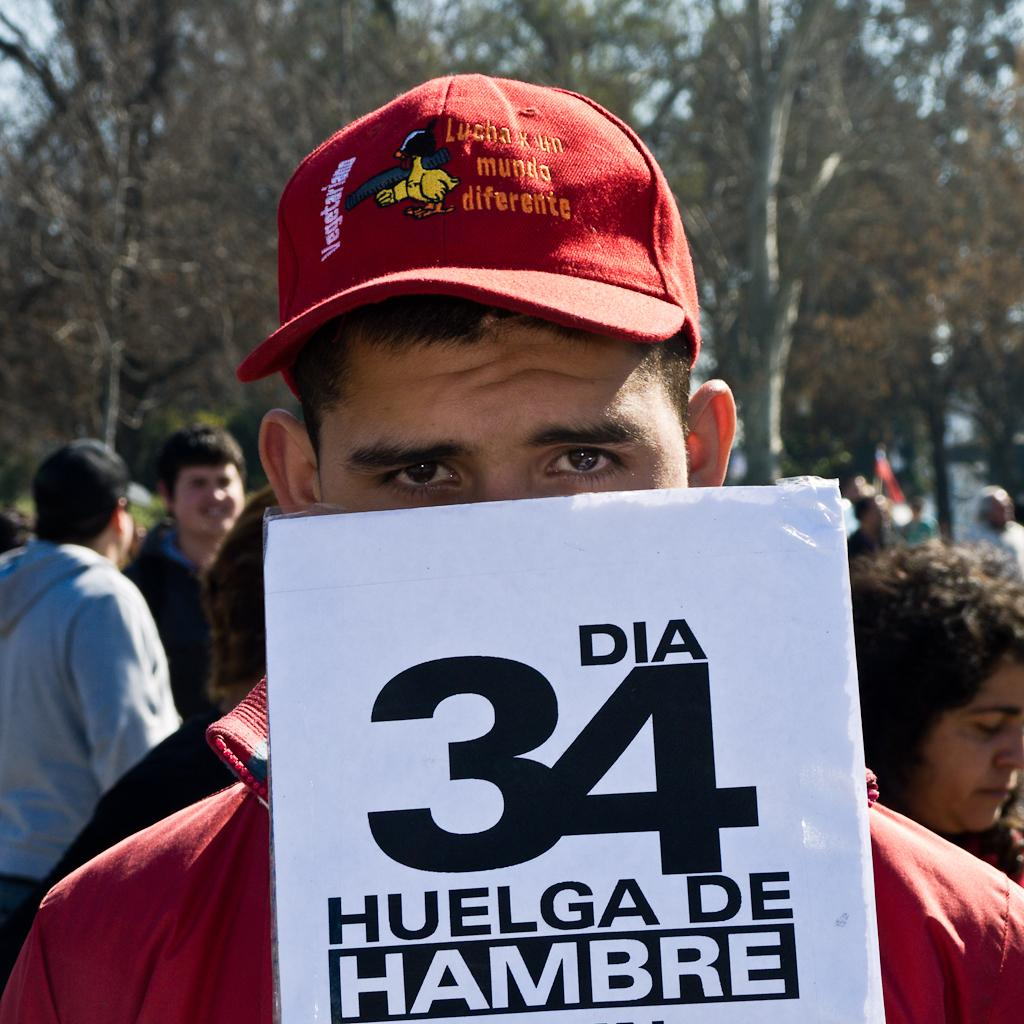How many people are in the image? There are multiple persons in the image. Can you describe the man in the front of the image? The man in the front of the image is holding some paper and wearing a cap. What is visible at the top of the image? There are trees visible at the top of the image. What color is the hydrant next to the man in the image? There is no hydrant present in the image. How does the afterthought affect the man's decision in the image? There is no mention of an afterthought or the man's decision in the image. 